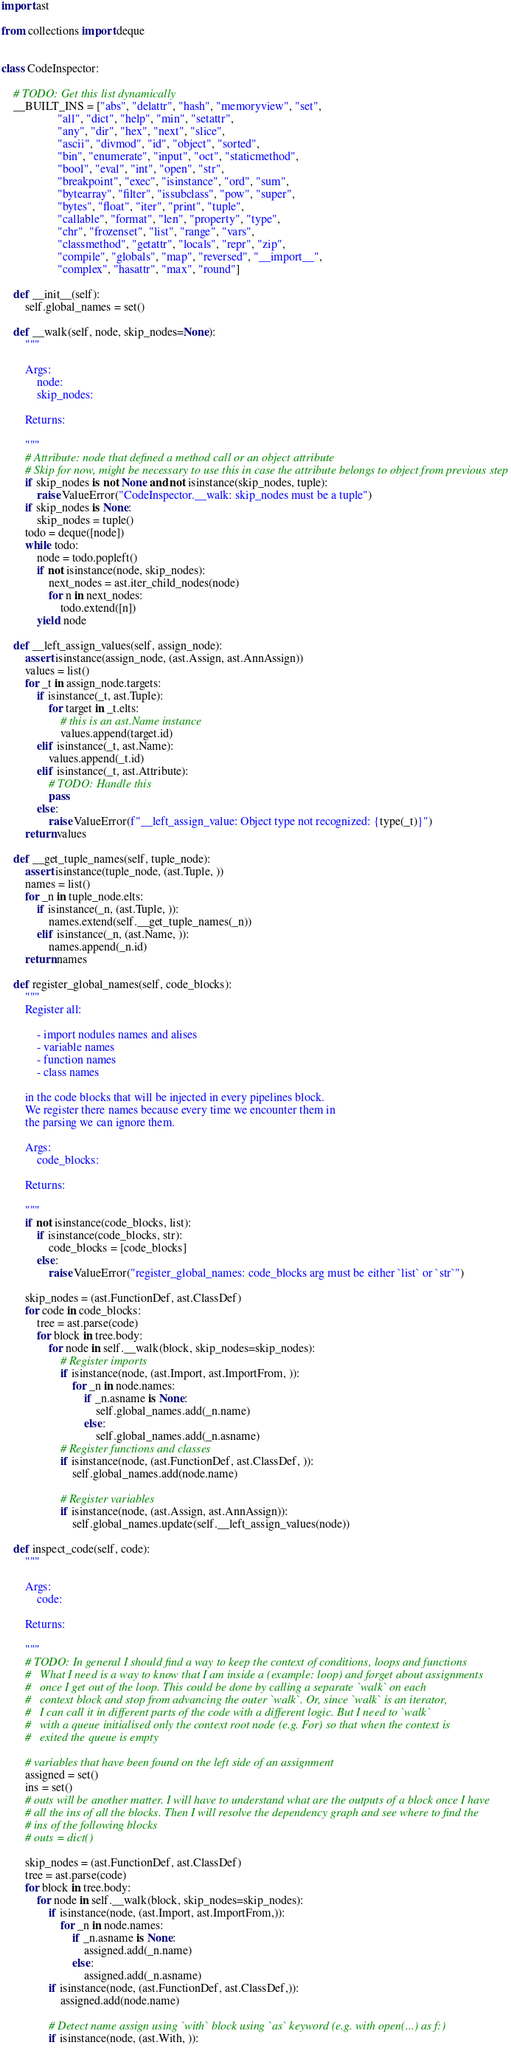<code> <loc_0><loc_0><loc_500><loc_500><_Python_>import ast

from collections import deque


class CodeInspector:

    # TODO: Get this list dynamically
    __BUILT_INS = ["abs", "delattr", "hash", "memoryview", "set",
                   "all", "dict", "help", "min", "setattr",
                   "any", "dir", "hex", "next", "slice",
                   "ascii", "divmod", "id", "object", "sorted",
                   "bin", "enumerate", "input", "oct", "staticmethod",
                   "bool", "eval", "int", "open", "str",
                   "breakpoint", "exec", "isinstance", "ord", "sum",
                   "bytearray", "filter", "issubclass", "pow", "super",
                   "bytes", "float", "iter", "print", "tuple",
                   "callable", "format", "len", "property", "type",
                   "chr", "frozenset", "list", "range", "vars",
                   "classmethod", "getattr", "locals", "repr", "zip",
                   "compile", "globals", "map", "reversed", "__import__",
                   "complex", "hasattr", "max", "round"]

    def __init__(self):
        self.global_names = set()

    def __walk(self, node, skip_nodes=None):
        """

        Args:
            node:
            skip_nodes:

        Returns:

        """
        # Attribute: node that defined a method call or an object attribute
        # Skip for now, might be necessary to use this in case the attribute belongs to object from previous step
        if skip_nodes is not None and not isinstance(skip_nodes, tuple):
            raise ValueError("CodeInspector.__walk: skip_nodes must be a tuple")
        if skip_nodes is None:
            skip_nodes = tuple()
        todo = deque([node])
        while todo:
            node = todo.popleft()
            if not isinstance(node, skip_nodes):
                next_nodes = ast.iter_child_nodes(node)
                for n in next_nodes:
                    todo.extend([n])
            yield node

    def __left_assign_values(self, assign_node):
        assert isinstance(assign_node, (ast.Assign, ast.AnnAssign))
        values = list()
        for _t in assign_node.targets:
            if isinstance(_t, ast.Tuple):
                for target in _t.elts:
                    # this is an ast.Name instance
                    values.append(target.id)
            elif isinstance(_t, ast.Name):
                values.append(_t.id)
            elif isinstance(_t, ast.Attribute):
                # TODO: Handle this
                pass
            else:
                raise ValueError(f"__left_assign_value: Object type not recognized: {type(_t)}")
        return values

    def __get_tuple_names(self, tuple_node):
        assert isinstance(tuple_node, (ast.Tuple, ))
        names = list()
        for _n in tuple_node.elts:
            if isinstance(_n, (ast.Tuple, )):
                names.extend(self.__get_tuple_names(_n))
            elif isinstance(_n, (ast.Name, )):
                names.append(_n.id)
        return names

    def register_global_names(self, code_blocks):
        """
        Register all:

            - import nodules names and alises
            - variable names
            - function names
            - class names

        in the code blocks that will be injected in every pipelines block.
        We register there names because every time we encounter them in
        the parsing we can ignore them.

        Args:
            code_blocks:

        Returns:

        """
        if not isinstance(code_blocks, list):
            if isinstance(code_blocks, str):
                code_blocks = [code_blocks]
            else:
                raise ValueError("register_global_names: code_blocks arg must be either `list` or `str`")

        skip_nodes = (ast.FunctionDef, ast.ClassDef)
        for code in code_blocks:
            tree = ast.parse(code)
            for block in tree.body:
                for node in self.__walk(block, skip_nodes=skip_nodes):
                    # Register imports
                    if isinstance(node, (ast.Import, ast.ImportFrom, )):
                        for _n in node.names:
                            if _n.asname is None:
                                self.global_names.add(_n.name)
                            else:
                                self.global_names.add(_n.asname)
                    # Register functions and classes
                    if isinstance(node, (ast.FunctionDef, ast.ClassDef, )):
                        self.global_names.add(node.name)

                    # Register variables
                    if isinstance(node, (ast.Assign, ast.AnnAssign)):
                        self.global_names.update(self.__left_assign_values(node))

    def inspect_code(self, code):
        """

        Args:
            code:

        Returns:

        """
        # TODO: In general I should find a way to keep the context of conditions, loops and functions
        #   What I need is a way to know that I am inside a (example: loop) and forget about assignments
        #   once I get out of the loop. This could be done by calling a separate `walk` on each
        #   context block and stop from advancing the outer `walk`. Or, since `walk` is an iterator,
        #   I can call it in different parts of the code with a different logic. But I need to `walk`
        #   with a queue initialised only the context root node (e.g. For) so that when the context is
        #   exited the queue is empty

        # variables that have been found on the left side of an assignment
        assigned = set()
        ins = set()
        # outs will be another matter. I will have to understand what are the outputs of a block once I have
        # all the ins of all the blocks. Then I will resolve the dependency graph and see where to find the
        # ins of the following blocks
        # outs = dict()

        skip_nodes = (ast.FunctionDef, ast.ClassDef)
        tree = ast.parse(code)
        for block in tree.body:
            for node in self.__walk(block, skip_nodes=skip_nodes):
                if isinstance(node, (ast.Import, ast.ImportFrom,)):
                    for _n in node.names:
                        if _n.asname is None:
                            assigned.add(_n.name)
                        else:
                            assigned.add(_n.asname)
                if isinstance(node, (ast.FunctionDef, ast.ClassDef,)):
                    assigned.add(node.name)

                # Detect name assign using `with` block using `as` keyword (e.g. with open(...) as f:)
                if isinstance(node, (ast.With, )):</code> 